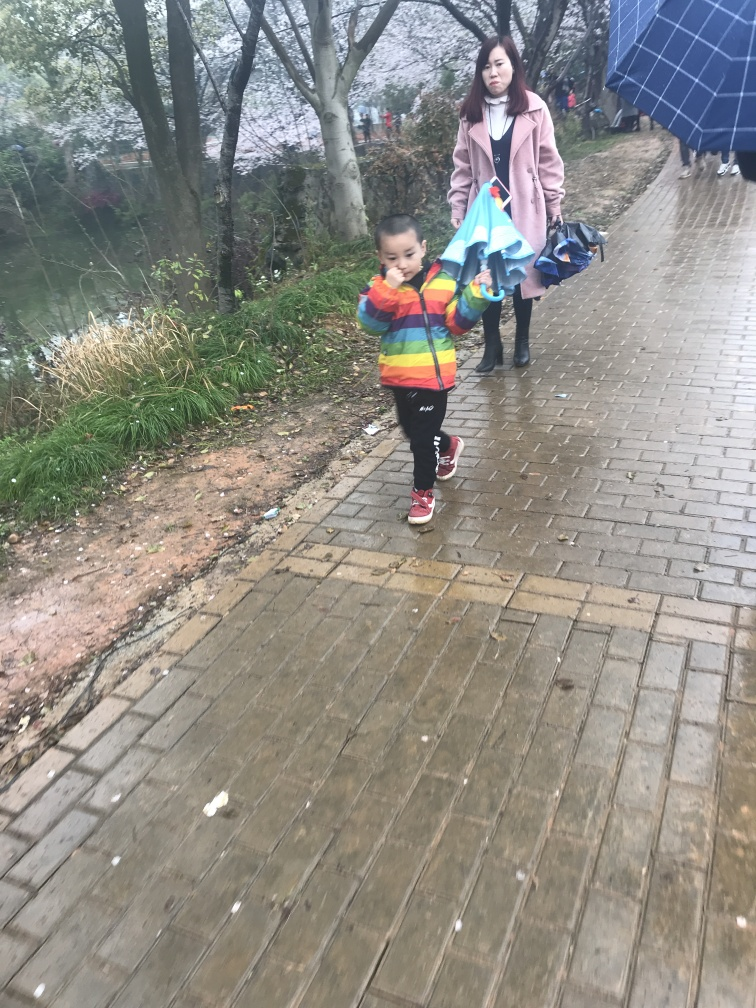Can you describe the weather or season depicted in the image? The weather seems overcast, and the presence of bare branches suggests it might be late autumn or early spring. The adult is wearing a coat, indicating a cooler temperature, and the ground appears to be wet, perhaps after a recent rain. 